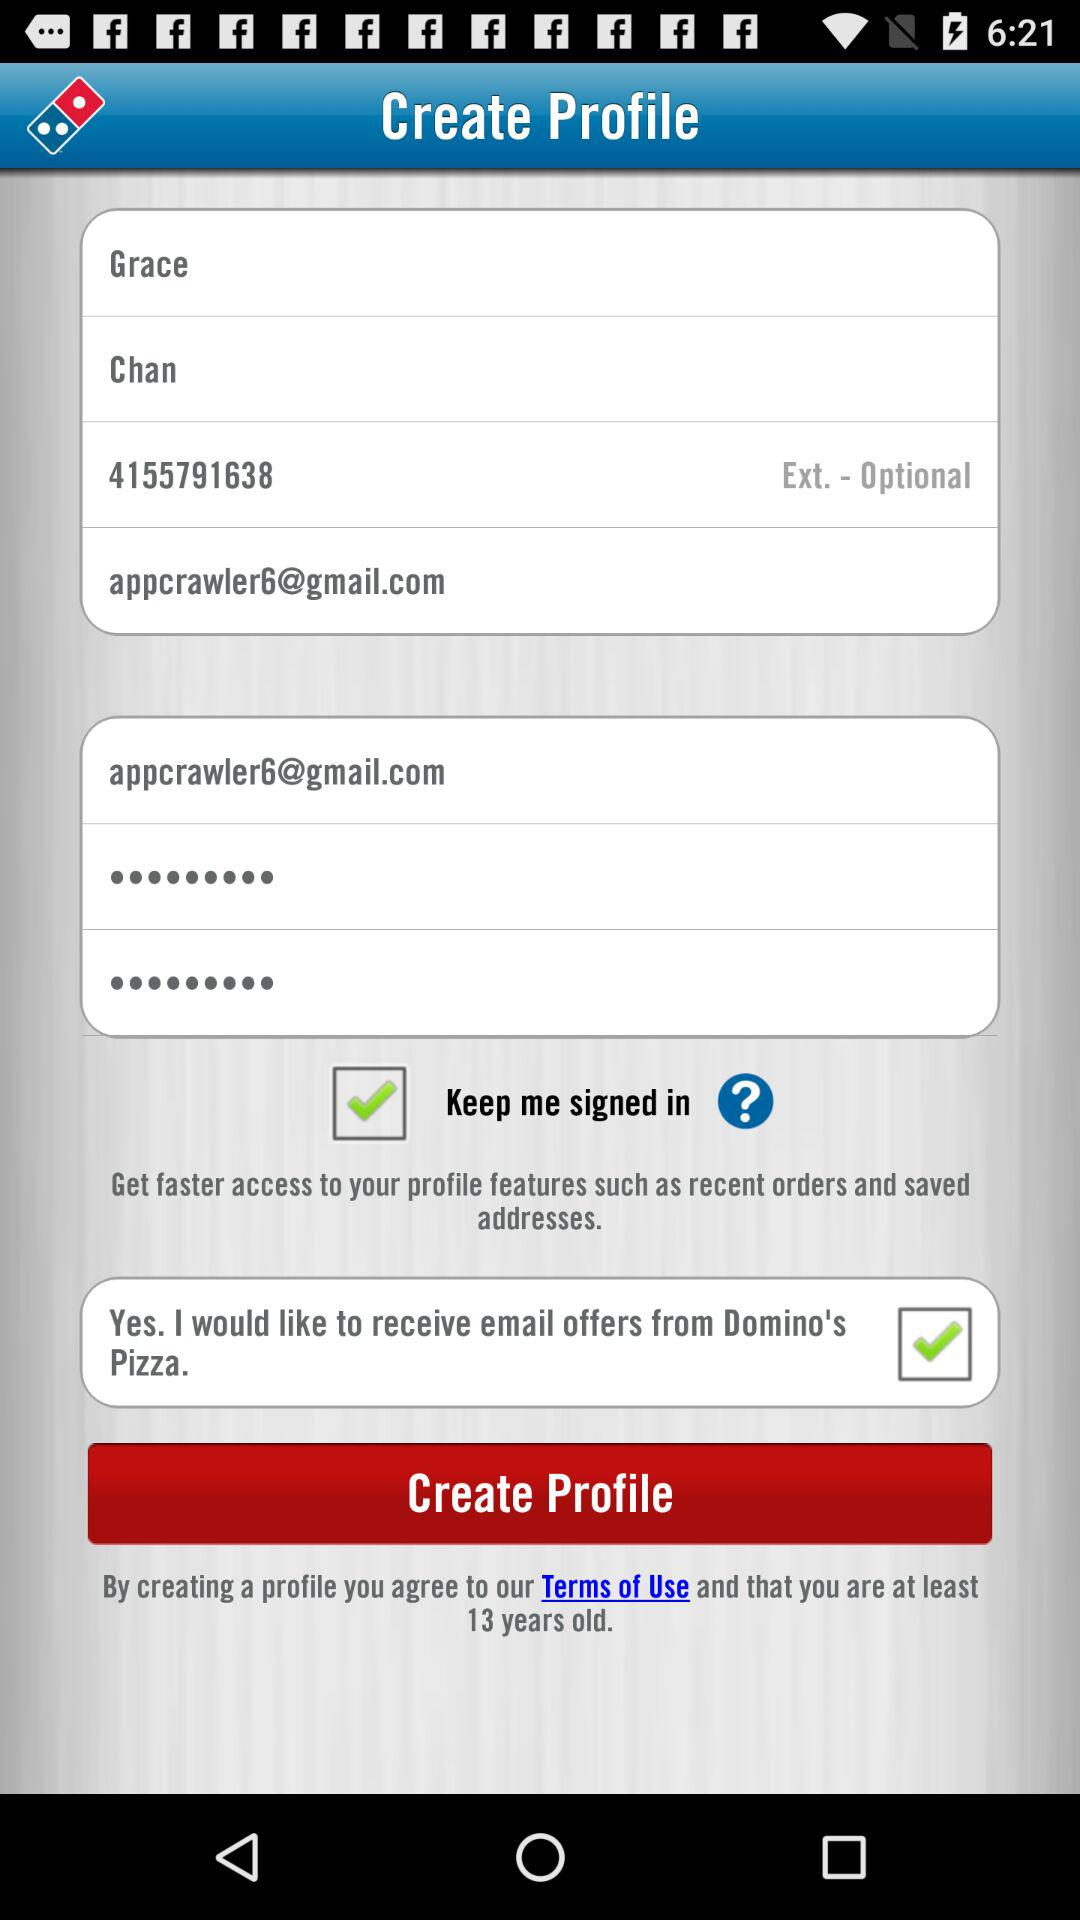What is the last name? The last name is Chan. 